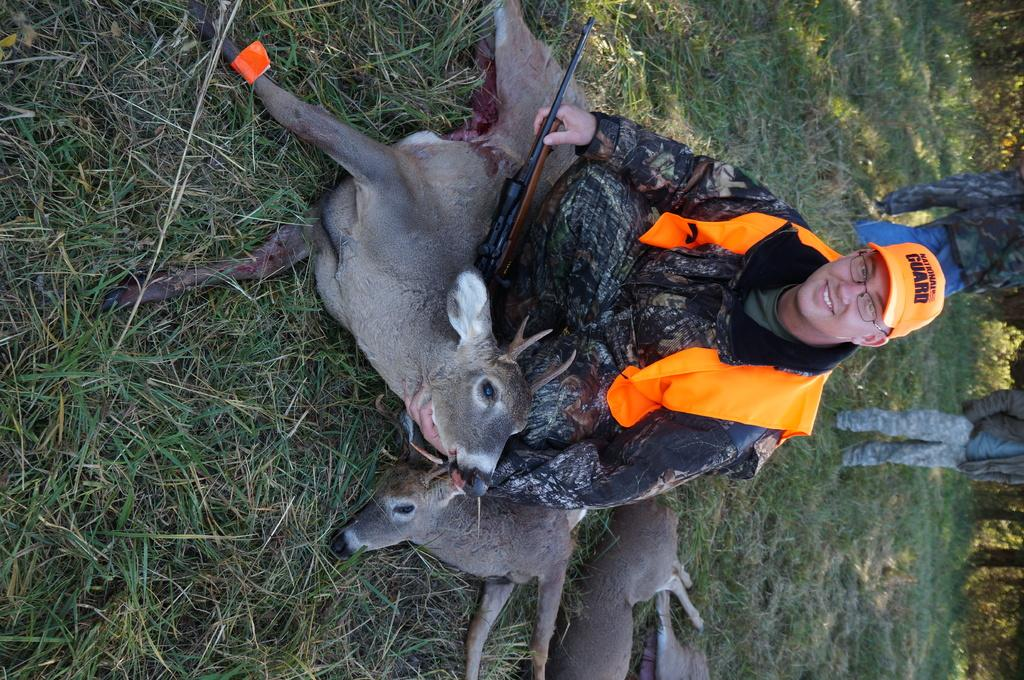What is the main subject in the center of the image? There is a person sitting in the center of the image. What animals can be seen in the image? There are deers on the grass in the image. What type of vegetation is visible in the image? Grass is visible in the image. What can be seen in the background of the image? There are trees and other persons in the background of the image. What type of picture is the person holding in the image? There is no picture visible in the image; the person is sitting and not holding anything. 